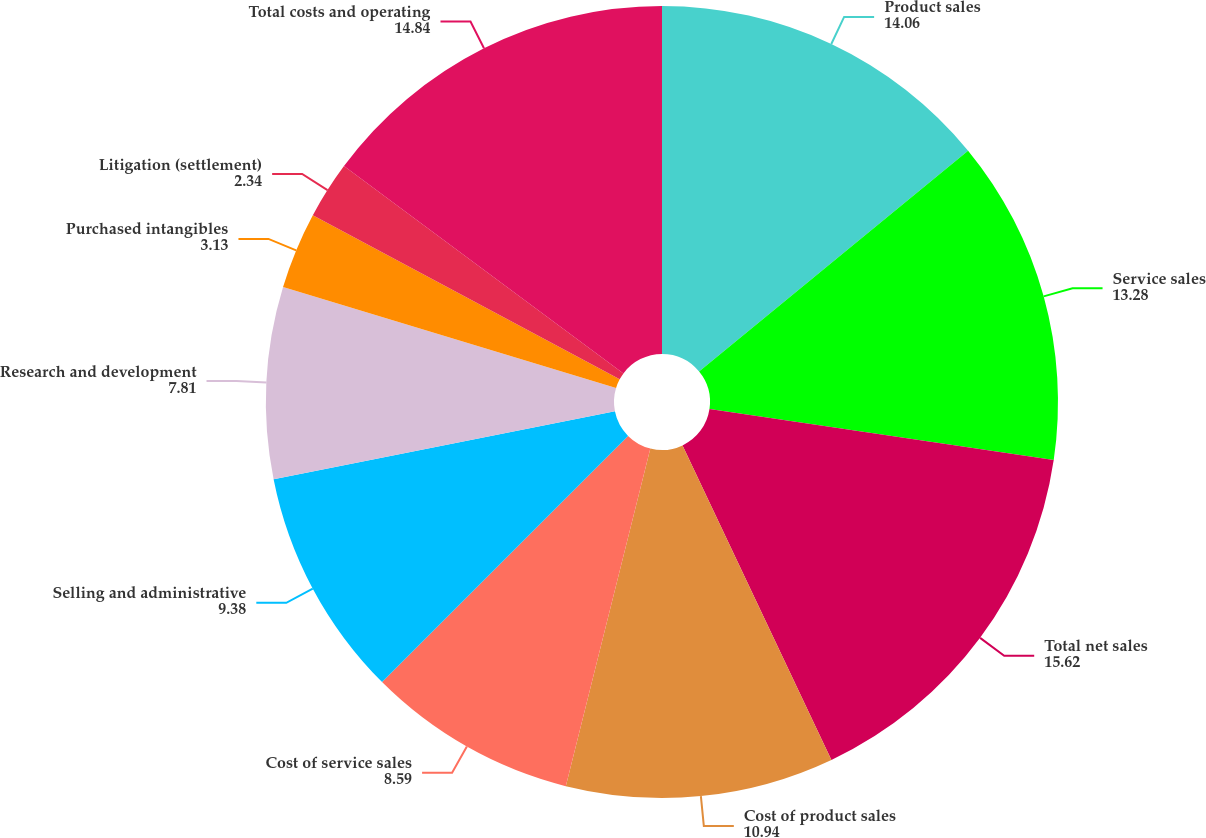<chart> <loc_0><loc_0><loc_500><loc_500><pie_chart><fcel>Product sales<fcel>Service sales<fcel>Total net sales<fcel>Cost of product sales<fcel>Cost of service sales<fcel>Selling and administrative<fcel>Research and development<fcel>Purchased intangibles<fcel>Litigation (settlement)<fcel>Total costs and operating<nl><fcel>14.06%<fcel>13.28%<fcel>15.62%<fcel>10.94%<fcel>8.59%<fcel>9.38%<fcel>7.81%<fcel>3.13%<fcel>2.34%<fcel>14.84%<nl></chart> 